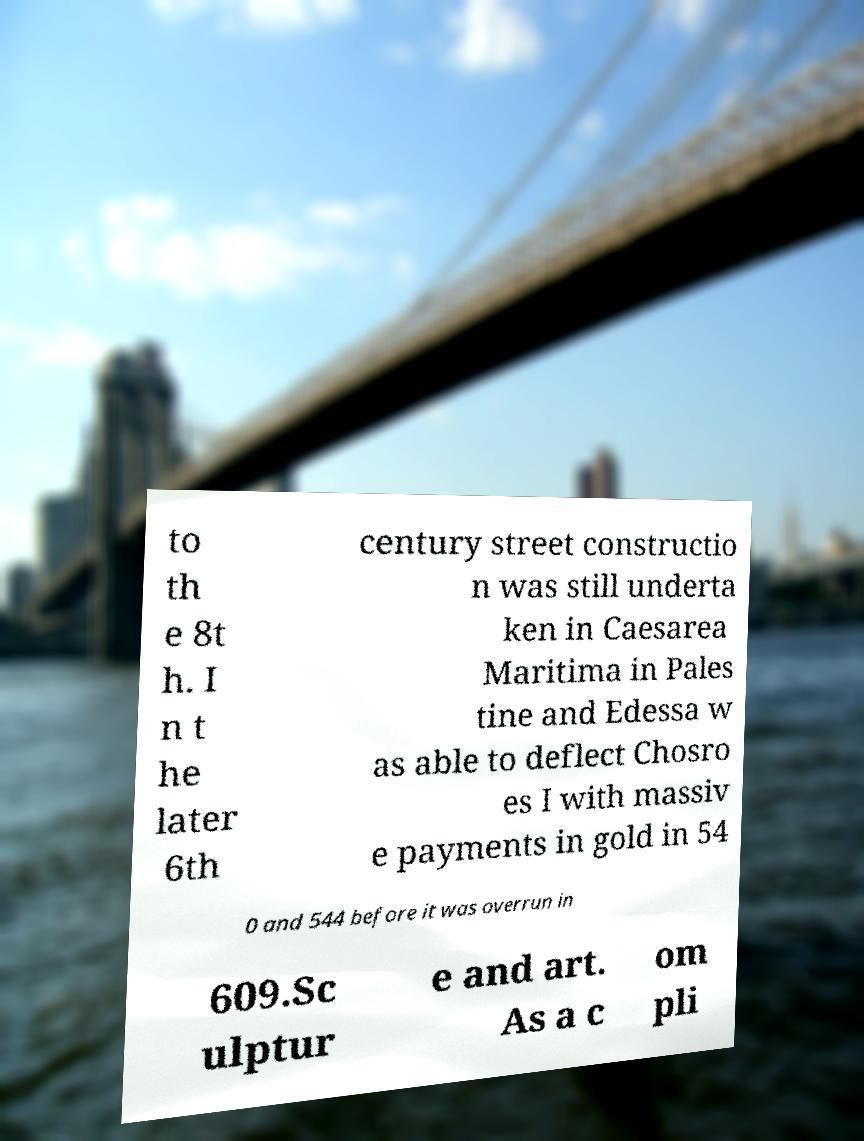What messages or text are displayed in this image? I need them in a readable, typed format. to th e 8t h. I n t he later 6th century street constructio n was still underta ken in Caesarea Maritima in Pales tine and Edessa w as able to deflect Chosro es I with massiv e payments in gold in 54 0 and 544 before it was overrun in 609.Sc ulptur e and art. As a c om pli 